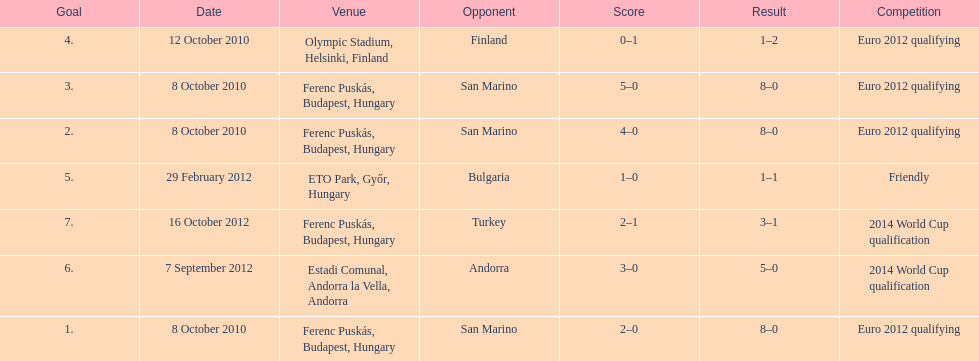How many games did he score but his team lost? 1. 